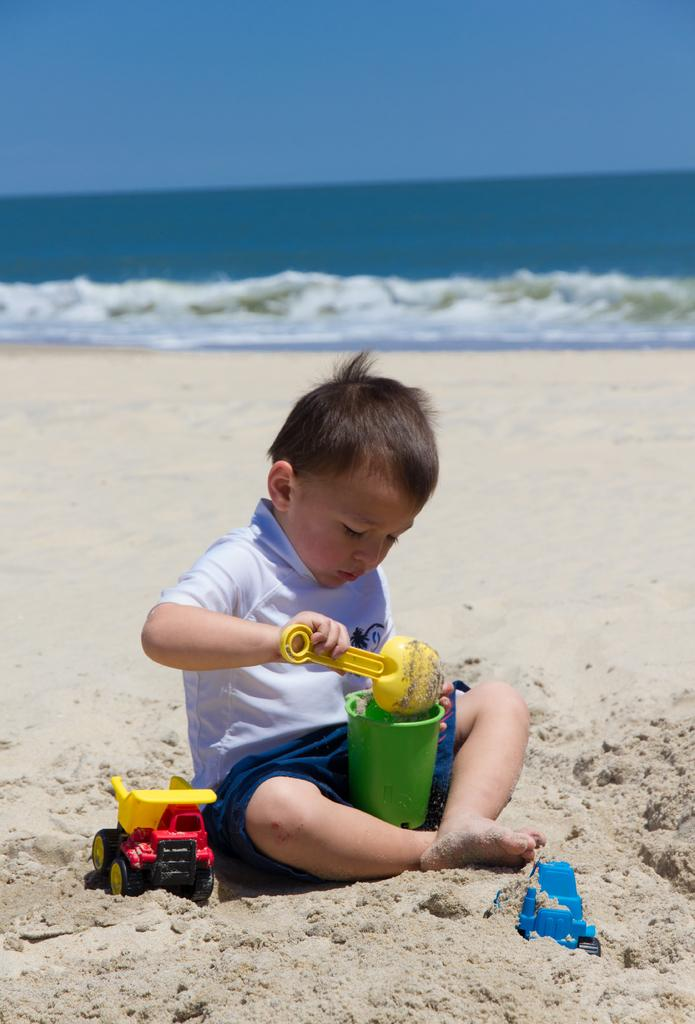What is the main subject of the image? There is a kid in the image. What is the kid holding in the image? The kid is holding some objects. What type of surface is visible in the image? There is ground with sand in the image. What else can be seen on the ground? There are toys on the ground. What else is visible in the image besides the ground? There is water and the sky visible in the image. What type of design can be seen on the stone in the image? There is no stone present in the image, so it is not possible to answer that question. 